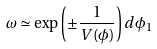Convert formula to latex. <formula><loc_0><loc_0><loc_500><loc_500>\omega \simeq \exp \left ( \pm \frac { 1 } { V ( \phi ) } \right ) d \phi _ { 1 }</formula> 